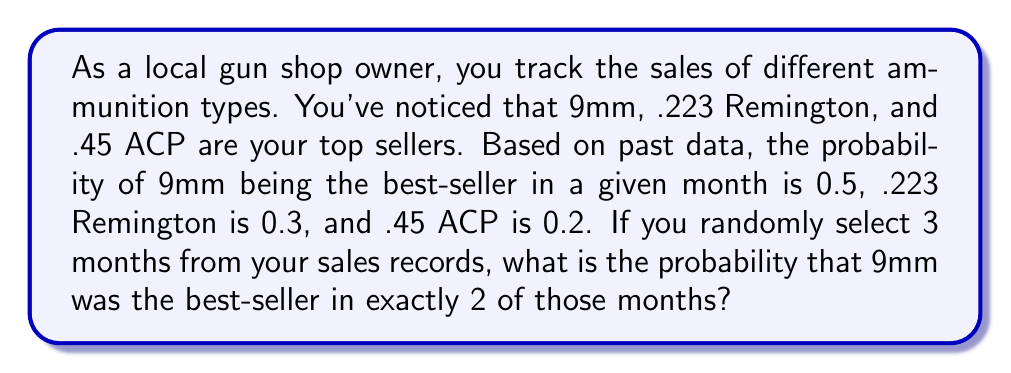What is the answer to this math problem? To solve this problem, we'll use the binomial probability formula. This scenario fits a binomial distribution because:

1. We have a fixed number of trials (3 months)
2. Each trial has two possible outcomes (9mm is best-seller or it's not)
3. The probability of success (9mm being best-seller) is constant for each trial
4. The trials are independent

The binomial probability formula is:

$$ P(X = k) = \binom{n}{k} p^k (1-p)^{n-k} $$

Where:
$n$ = number of trials (3 months)
$k$ = number of successes (2 months where 9mm is best-seller)
$p$ = probability of success on each trial (0.5 for 9mm)

Let's calculate:

1. $\binom{n}{k} = \binom{3}{2} = \frac{3!}{2!(3-2)!} = \frac{3 \cdot 2 \cdot 1}{(2 \cdot 1)(1)} = 3$

2. $p^k = 0.5^2 = 0.25$

3. $(1-p)^{n-k} = (1-0.5)^{3-2} = 0.5^1 = 0.5$

Now, let's plug these values into the formula:

$$ P(X = 2) = 3 \cdot 0.25 \cdot 0.5 = 0.375 $$
Answer: The probability that 9mm ammunition was the best-seller in exactly 2 out of 3 randomly selected months is 0.375 or 37.5%. 